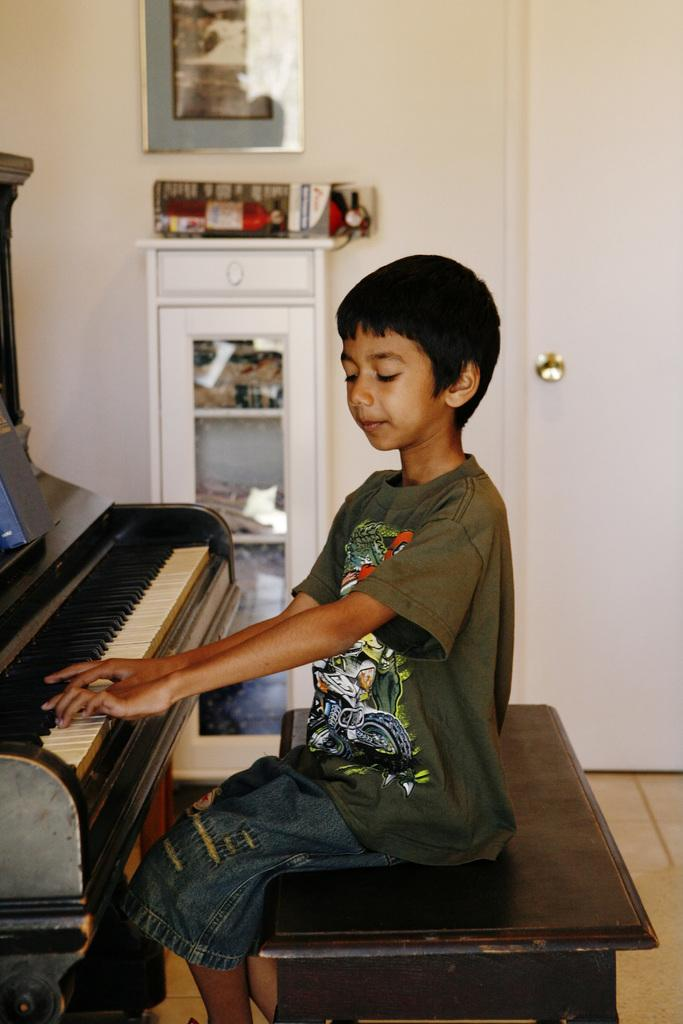Who is the main subject in the picture? There is a boy in the picture. What is the boy doing in the picture? The boy is sitting on a bench and playing the piano. Can you describe any furniture or fixtures in the room? There is a cabinet attached to the wall, and a picture frame is fixed to the cabinet. Is there any entrance or exit in the room? Yes, there is a door in the room. What types of toys are scattered around the boy's feet in the image? There are no toys visible in the image; the boy is playing the piano while sitting on a bench. 